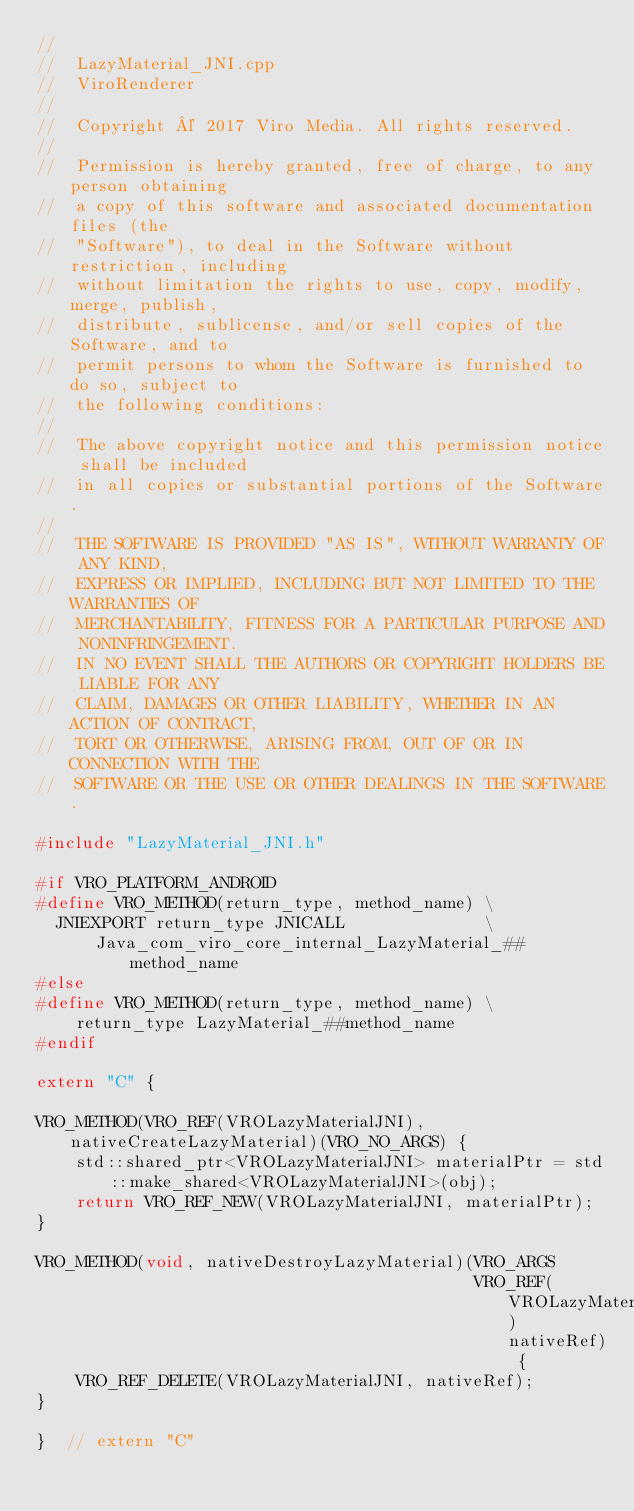<code> <loc_0><loc_0><loc_500><loc_500><_C++_>//
//  LazyMaterial_JNI.cpp
//  ViroRenderer
//
//  Copyright © 2017 Viro Media. All rights reserved.
//
//  Permission is hereby granted, free of charge, to any person obtaining
//  a copy of this software and associated documentation files (the
//  "Software"), to deal in the Software without restriction, including
//  without limitation the rights to use, copy, modify, merge, publish,
//  distribute, sublicense, and/or sell copies of the Software, and to
//  permit persons to whom the Software is furnished to do so, subject to
//  the following conditions:
//
//  The above copyright notice and this permission notice shall be included
//  in all copies or substantial portions of the Software.
//
//  THE SOFTWARE IS PROVIDED "AS IS", WITHOUT WARRANTY OF ANY KIND,
//  EXPRESS OR IMPLIED, INCLUDING BUT NOT LIMITED TO THE WARRANTIES OF
//  MERCHANTABILITY, FITNESS FOR A PARTICULAR PURPOSE AND NONINFRINGEMENT.
//  IN NO EVENT SHALL THE AUTHORS OR COPYRIGHT HOLDERS BE LIABLE FOR ANY
//  CLAIM, DAMAGES OR OTHER LIABILITY, WHETHER IN AN ACTION OF CONTRACT,
//  TORT OR OTHERWISE, ARISING FROM, OUT OF OR IN CONNECTION WITH THE
//  SOFTWARE OR THE USE OR OTHER DEALINGS IN THE SOFTWARE.

#include "LazyMaterial_JNI.h"

#if VRO_PLATFORM_ANDROID
#define VRO_METHOD(return_type, method_name) \
  JNIEXPORT return_type JNICALL              \
      Java_com_viro_core_internal_LazyMaterial_##method_name
#else
#define VRO_METHOD(return_type, method_name) \
    return_type LazyMaterial_##method_name
#endif

extern "C" {

VRO_METHOD(VRO_REF(VROLazyMaterialJNI), nativeCreateLazyMaterial)(VRO_NO_ARGS) {
    std::shared_ptr<VROLazyMaterialJNI> materialPtr = std::make_shared<VROLazyMaterialJNI>(obj);
    return VRO_REF_NEW(VROLazyMaterialJNI, materialPtr);
}

VRO_METHOD(void, nativeDestroyLazyMaterial)(VRO_ARGS
                                            VRO_REF(VROLazyMaterialJNI) nativeRef) {
    VRO_REF_DELETE(VROLazyMaterialJNI, nativeRef);
}

}  // extern "C"</code> 